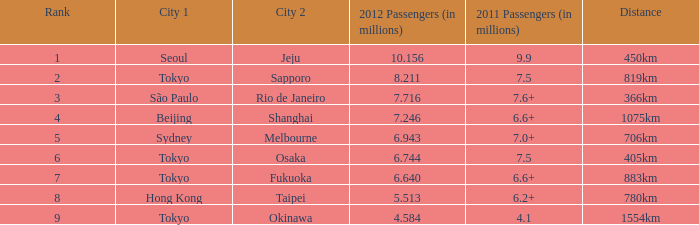Which is the initial city on the route that had over 6.6 million passengers in 2011 and a 1075km distance? Beijing. 